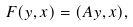<formula> <loc_0><loc_0><loc_500><loc_500>F ( y , x ) & = ( A y , x ) ,</formula> 